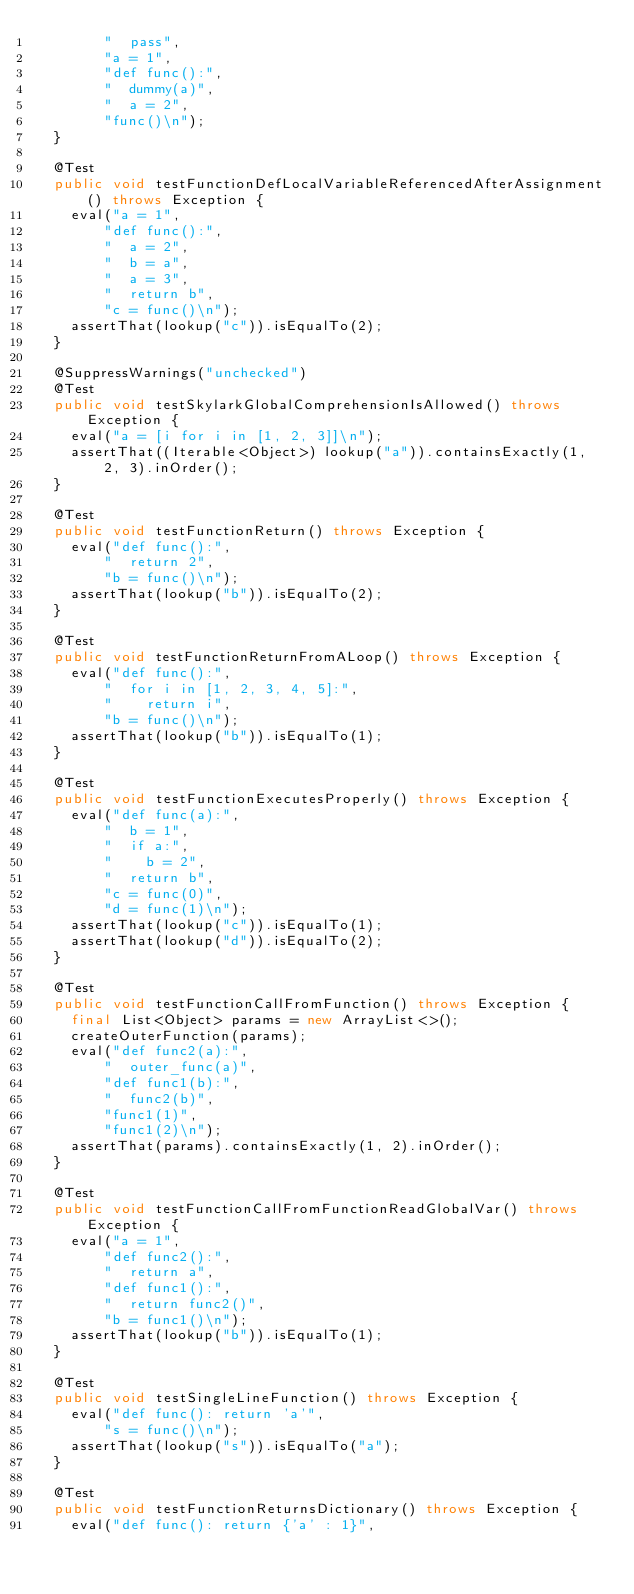Convert code to text. <code><loc_0><loc_0><loc_500><loc_500><_Java_>        "  pass",
        "a = 1",
        "def func():",
        "  dummy(a)",
        "  a = 2",
        "func()\n");
  }

  @Test
  public void testFunctionDefLocalVariableReferencedAfterAssignment() throws Exception {
    eval("a = 1",
        "def func():",
        "  a = 2",
        "  b = a",
        "  a = 3",
        "  return b",
        "c = func()\n");
    assertThat(lookup("c")).isEqualTo(2);
  }

  @SuppressWarnings("unchecked")
  @Test
  public void testSkylarkGlobalComprehensionIsAllowed() throws Exception {
    eval("a = [i for i in [1, 2, 3]]\n");
    assertThat((Iterable<Object>) lookup("a")).containsExactly(1, 2, 3).inOrder();
  }

  @Test
  public void testFunctionReturn() throws Exception {
    eval("def func():",
        "  return 2",
        "b = func()\n");
    assertThat(lookup("b")).isEqualTo(2);
  }

  @Test
  public void testFunctionReturnFromALoop() throws Exception {
    eval("def func():",
        "  for i in [1, 2, 3, 4, 5]:",
        "    return i",
        "b = func()\n");
    assertThat(lookup("b")).isEqualTo(1);
  }

  @Test
  public void testFunctionExecutesProperly() throws Exception {
    eval("def func(a):",
        "  b = 1",
        "  if a:",
        "    b = 2",
        "  return b",
        "c = func(0)",
        "d = func(1)\n");
    assertThat(lookup("c")).isEqualTo(1);
    assertThat(lookup("d")).isEqualTo(2);
  }

  @Test
  public void testFunctionCallFromFunction() throws Exception {
    final List<Object> params = new ArrayList<>();
    createOuterFunction(params);
    eval("def func2(a):",
        "  outer_func(a)",
        "def func1(b):",
        "  func2(b)",
        "func1(1)",
        "func1(2)\n");
    assertThat(params).containsExactly(1, 2).inOrder();
  }

  @Test
  public void testFunctionCallFromFunctionReadGlobalVar() throws Exception {
    eval("a = 1",
        "def func2():",
        "  return a",
        "def func1():",
        "  return func2()",
        "b = func1()\n");
    assertThat(lookup("b")).isEqualTo(1);
  }

  @Test
  public void testSingleLineFunction() throws Exception {
    eval("def func(): return 'a'",
        "s = func()\n");
    assertThat(lookup("s")).isEqualTo("a");
  }

  @Test
  public void testFunctionReturnsDictionary() throws Exception {
    eval("def func(): return {'a' : 1}",</code> 